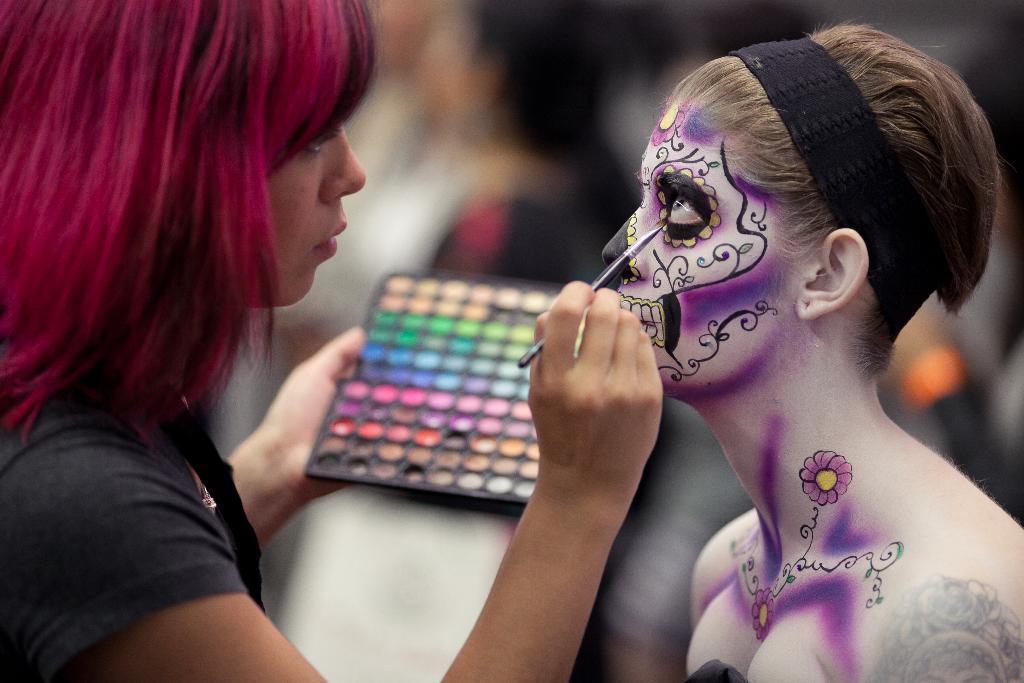Could you give a brief overview of what you see in this image? In this picture I can see two women among them the woman on the left side is holding objects in the hands. The woman on the right side is wearing a black color object on the head. 